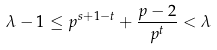<formula> <loc_0><loc_0><loc_500><loc_500>\lambda - 1 \leq p ^ { s + 1 - t } + \frac { p - 2 } { p ^ { t } } < \lambda</formula> 